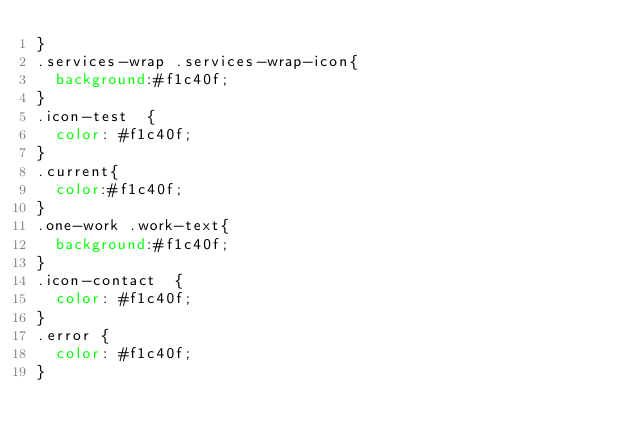<code> <loc_0><loc_0><loc_500><loc_500><_CSS_>}
.services-wrap .services-wrap-icon{
	background:#f1c40f;
}
.icon-test  {
	color: #f1c40f; 
}
.current{
	color:#f1c40f;
}
.one-work .work-text{
	background:#f1c40f; 
}
.icon-contact  {
	color: #f1c40f; 
}
.error {
	color: #f1c40f;
}





















</code> 